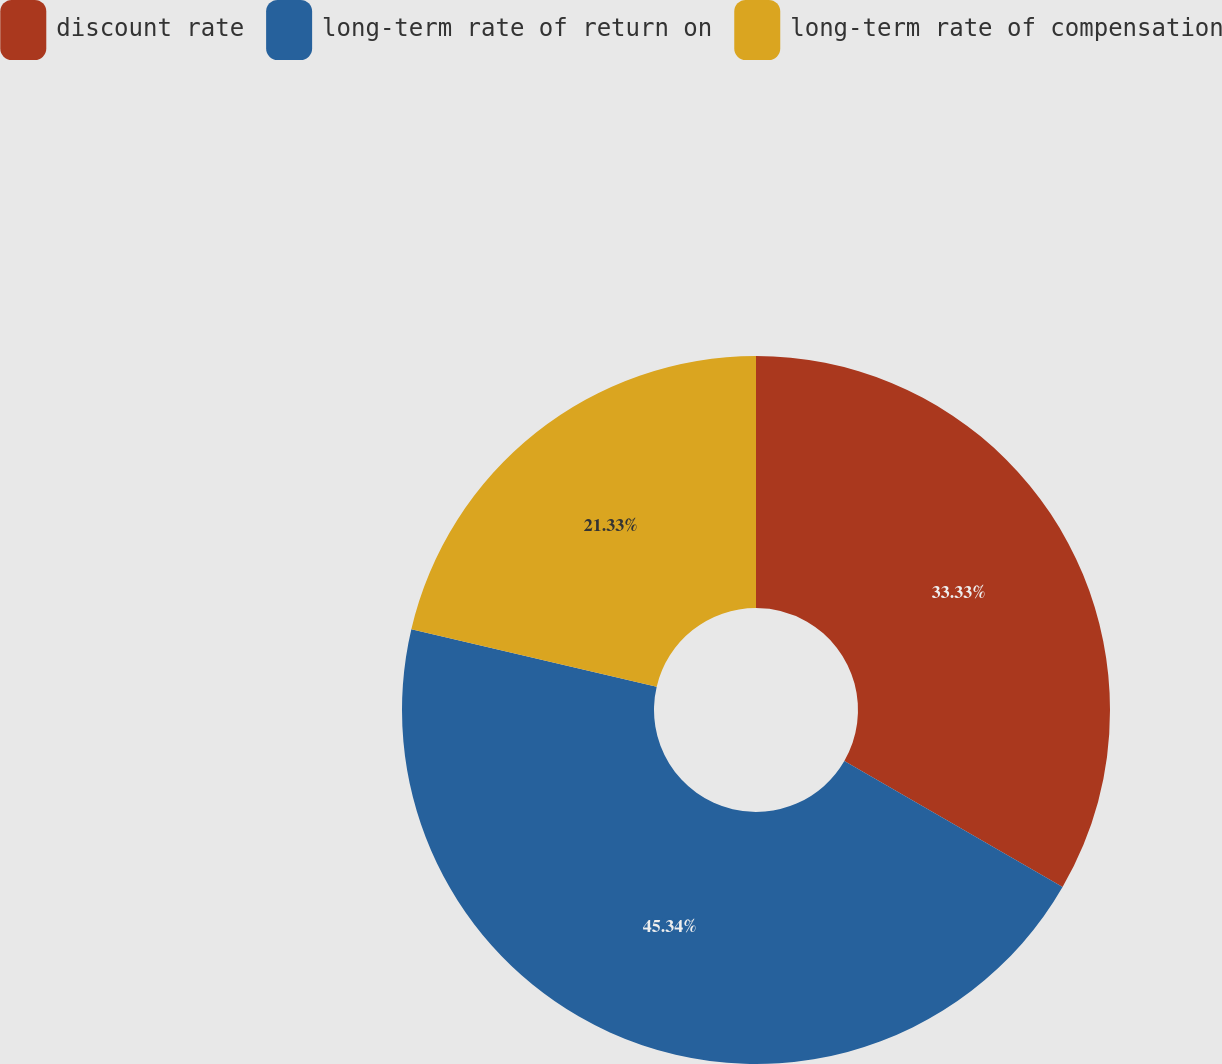<chart> <loc_0><loc_0><loc_500><loc_500><pie_chart><fcel>discount rate<fcel>long-term rate of return on<fcel>long-term rate of compensation<nl><fcel>33.33%<fcel>45.33%<fcel>21.33%<nl></chart> 